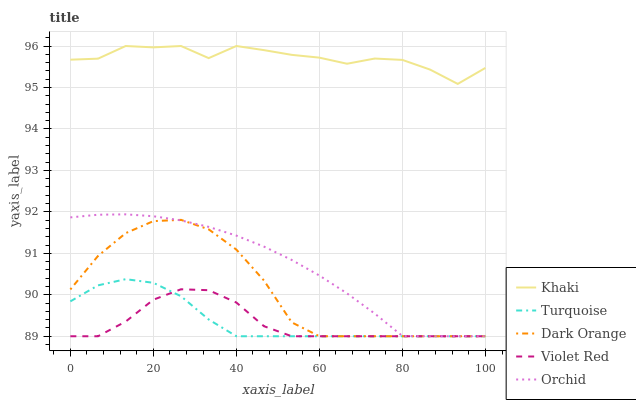Does Violet Red have the minimum area under the curve?
Answer yes or no. Yes. Does Khaki have the maximum area under the curve?
Answer yes or no. Yes. Does Turquoise have the minimum area under the curve?
Answer yes or no. No. Does Turquoise have the maximum area under the curve?
Answer yes or no. No. Is Orchid the smoothest?
Answer yes or no. Yes. Is Khaki the roughest?
Answer yes or no. Yes. Is Turquoise the smoothest?
Answer yes or no. No. Is Turquoise the roughest?
Answer yes or no. No. Does Dark Orange have the lowest value?
Answer yes or no. Yes. Does Khaki have the lowest value?
Answer yes or no. No. Does Khaki have the highest value?
Answer yes or no. Yes. Does Turquoise have the highest value?
Answer yes or no. No. Is Dark Orange less than Khaki?
Answer yes or no. Yes. Is Khaki greater than Turquoise?
Answer yes or no. Yes. Does Orchid intersect Violet Red?
Answer yes or no. Yes. Is Orchid less than Violet Red?
Answer yes or no. No. Is Orchid greater than Violet Red?
Answer yes or no. No. Does Dark Orange intersect Khaki?
Answer yes or no. No. 